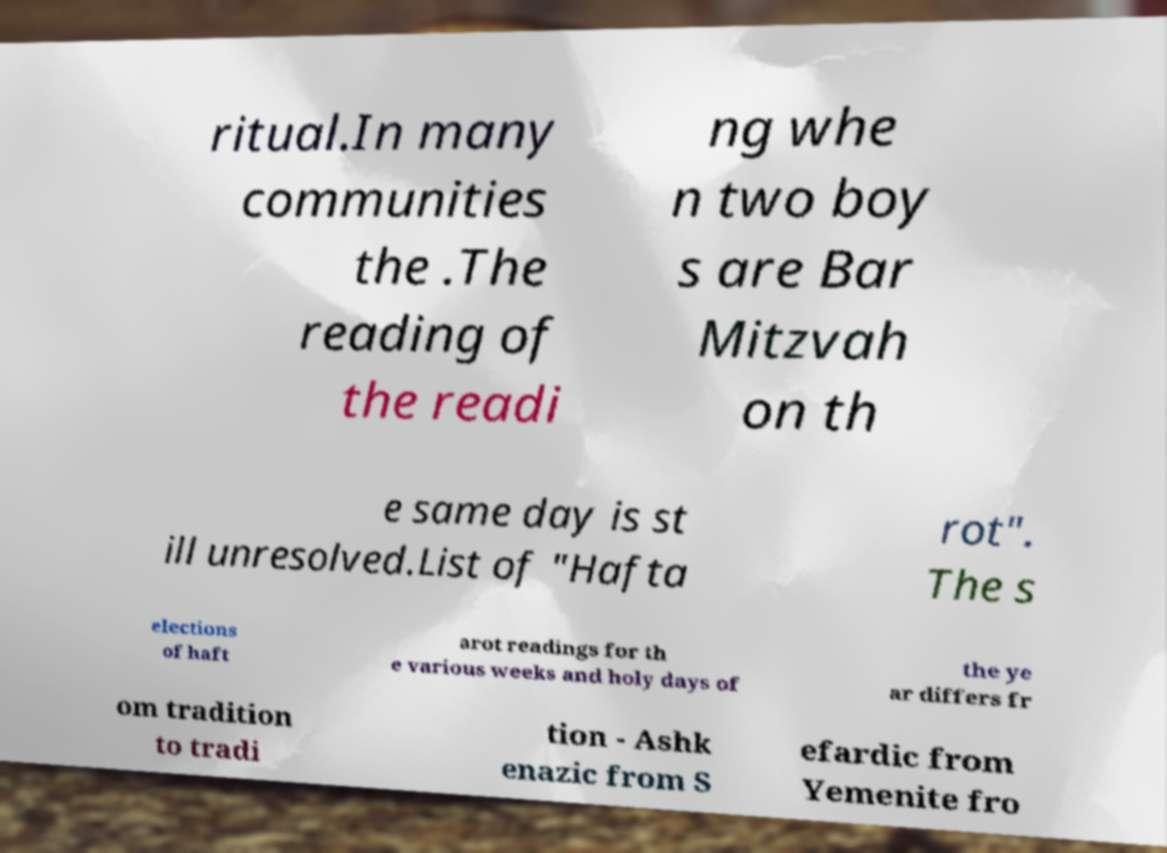What messages or text are displayed in this image? I need them in a readable, typed format. ritual.In many communities the .The reading of the readi ng whe n two boy s are Bar Mitzvah on th e same day is st ill unresolved.List of "Hafta rot". The s elections of haft arot readings for th e various weeks and holy days of the ye ar differs fr om tradition to tradi tion - Ashk enazic from S efardic from Yemenite fro 